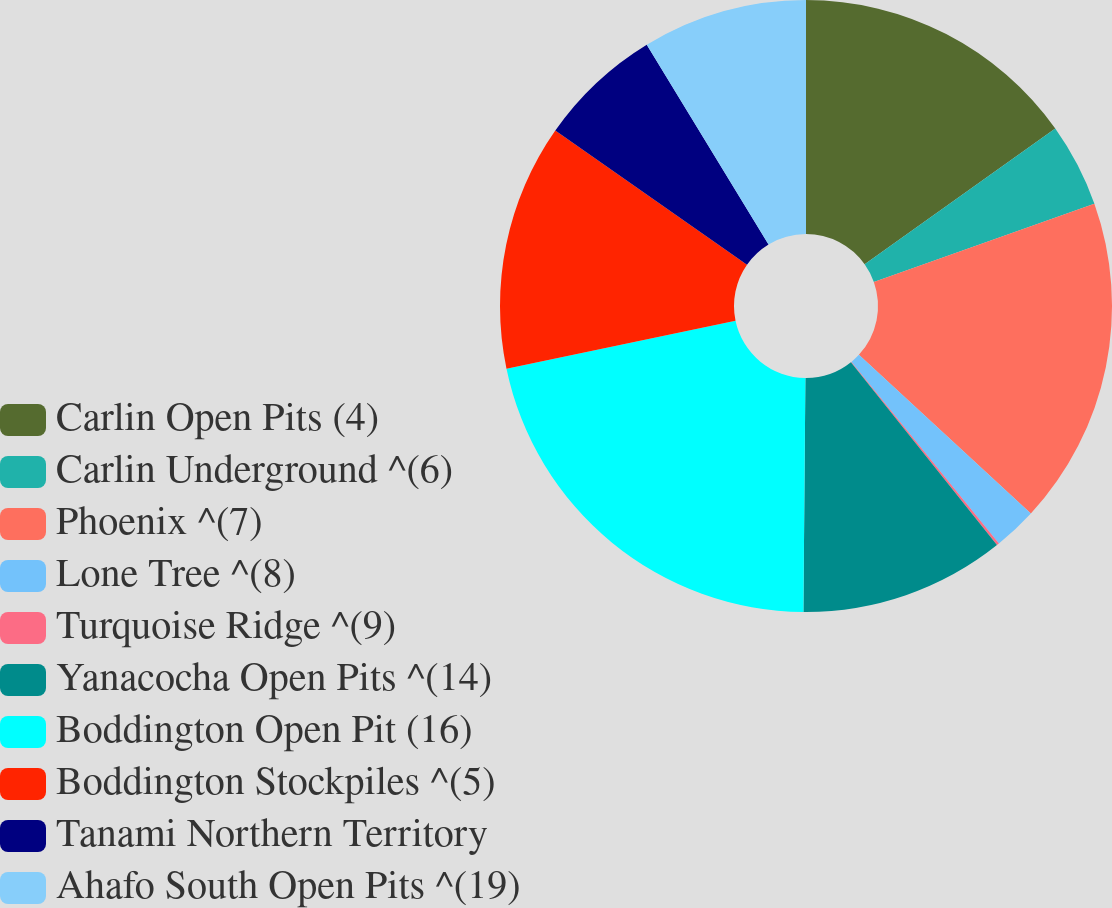<chart> <loc_0><loc_0><loc_500><loc_500><pie_chart><fcel>Carlin Open Pits (4)<fcel>Carlin Underground ^(6)<fcel>Phoenix ^(7)<fcel>Lone Tree ^(8)<fcel>Turquoise Ridge ^(9)<fcel>Yanacocha Open Pits ^(14)<fcel>Boddington Open Pit (16)<fcel>Boddington Stockpiles ^(5)<fcel>Tanami Northern Territory<fcel>Ahafo South Open Pits ^(19)<nl><fcel>15.15%<fcel>4.42%<fcel>17.29%<fcel>2.28%<fcel>0.13%<fcel>10.86%<fcel>21.58%<fcel>13.0%<fcel>6.57%<fcel>8.71%<nl></chart> 